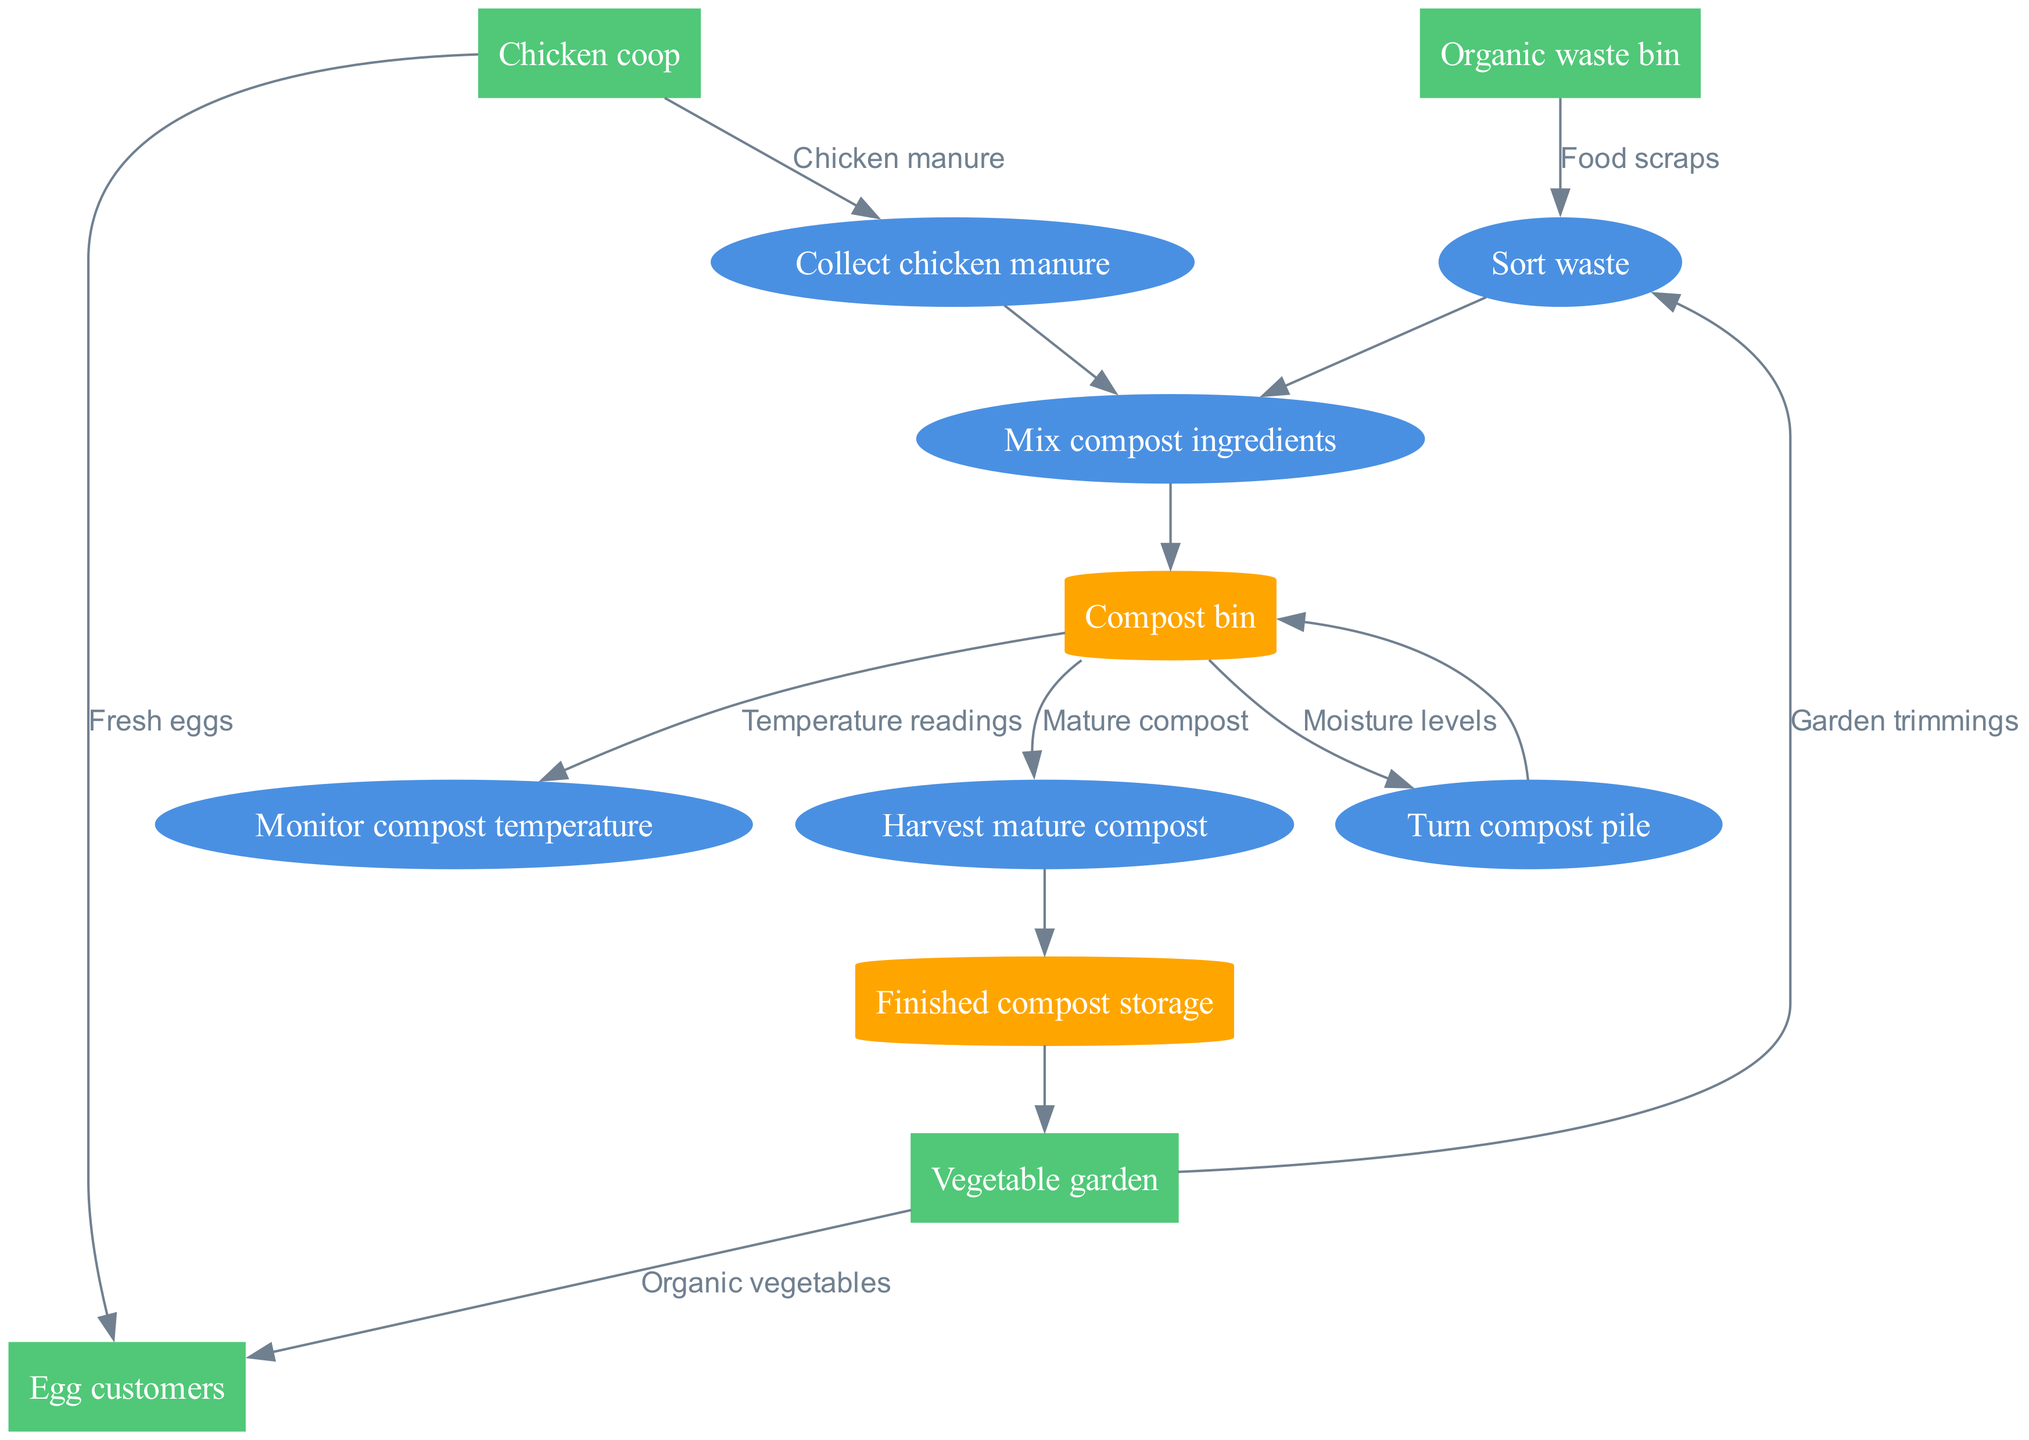What are the main processes shown in the diagram? The main processes are listed in the "processes" section of the data, which identifies six key actions in the composting and waste management process. These processes are "Sort waste," "Collect chicken manure," "Mix compost ingredients," "Monitor compost temperature," "Turn compost pile," and "Harvest mature compost."
Answer: Sort waste, Collect chicken manure, Mix compost ingredients, Monitor compost temperature, Turn compost pile, Harvest mature compost How many external entities are present in the diagram? The external entities section contains four distinct nodes: "Chicken coop," "Vegetable garden," "Organic waste bin," and "Egg customers." By counting these entities, we determine that there are four external entities in total.
Answer: 4 Which process comes after collecting chicken manure? The diagram indicates a directed flow from "Collect chicken manure" to "Mix compost ingredients." Therefore, the process that follows collecting chicken manure is mixing the compost ingredients.
Answer: Mix compost ingredients What data flows into the "Sort waste" process? The data flows into the "Sort waste" process include "Food scraps" from the "Organic waste bin" and "Garden trimmings" from the "Vegetable garden." Both of these flows are inputs for the sorting process.
Answer: Food scraps, Garden trimmings What is the final output stored in Finished compost storage? The output that is stored in the "Finished compost storage" is "Mature compost," which is the end product of the composting process indicated by the directed flow from "Harvest mature compost" to "Finished compost storage."
Answer: Mature compost What relationship exists between the "Compost bin" and "Monitor compost temperature"? The "Compost bin" provides the necessary data flow, specifically "Temperature readings," to the "Monitor compost temperature" process. This indicates a direct link in which the compost bin's conditions are monitored.
Answer: Temperature readings Which external entity receives fresh eggs from the chicken coop? The diagram shows a direct edge from the "Chicken coop" to "Egg customers," indicating that fresh eggs are supplied to egg customers.
Answer: Egg customers What happens after the compost pile is turned? After the "Turn compost pile" process, the flow returns back to the "Compost bin," indicating the ongoing nature of compost management where the turned pile remains within the composting system for further processing.
Answer: Compost bin 